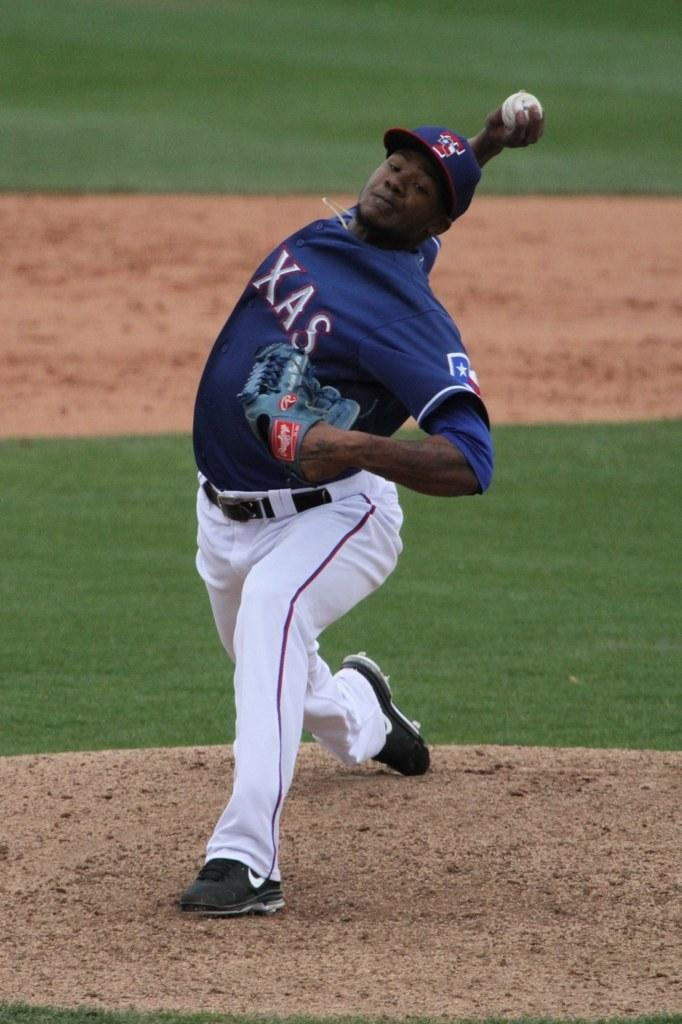Provide a one-sentence caption for the provided image. Baseball player wearing a Texas jersey pitching a ball. 